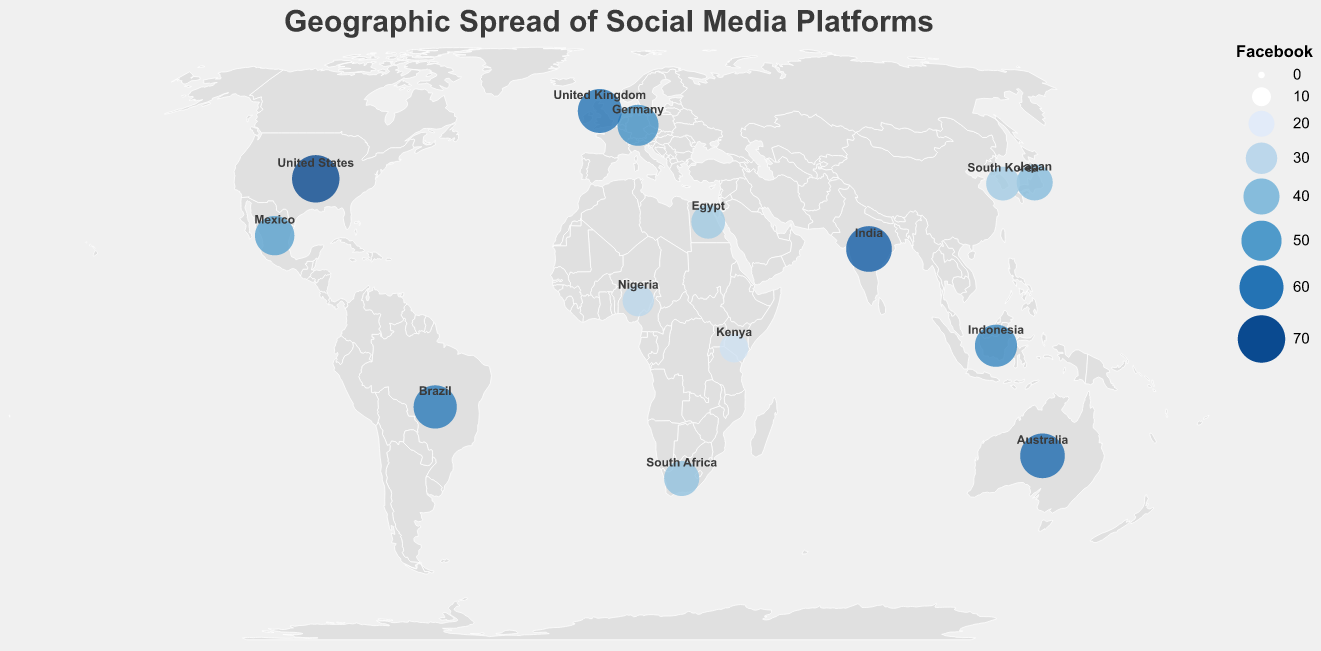What is the title of the figure? The title of the figure is displayed at the top and usually provides a concise summary of what the figure represents. In this case, the title is shown prominently in a specific font and color at the top of the figure.
Answer: Geographic Spread of Social Media Platforms Which country has the highest Facebook user base percentage? By scanning for the largest circle size or the deepest blue color, you can identify the country with the highest Facebook user base. According to the figure, the United States has Facebook usage at 70%.
Answer: United States How does Instagram usage compare between Brazil and Egypt? To compare Instagram usage, look at the tooltip data for both Brazil and Egypt. Brazil has 42% Instagram usage while Egypt has 20%. Hence, Instagram usage in Brazil is higher.
Answer: Brazil has higher Instagram usage Which country has the lowest percentage of Twitter users and what is that percentage? Identify the smallest circle for Twitter users or check the tooltip data for each country. Kenya has the lowest Twitter usage at 6%.
Answer: Kenya with 6% What is the sum of TikTok user base percentages in Indonesia and Japan? Find the TikTok usage percentages for Indonesia and Japan from their tooltips, which are 36% and 18% respectively. Adding these values gives 36 + 18 = 54%.
Answer: 54% How many countries have a Facebook user base percentage greater than 50%? Look at the Facebook usage percentages for each country and count those with values above 50%. The countries are the United States, India, Brazil, Indonesia, Australia, Germany, and the United Kingdom, making a total of 7 countries.
Answer: 7 What is the average Instagram user base percentage across all countries? Sum all Instagram percentages and divide by the number of countries. The sum is 37 + 32 + 42 + 39 + 18 + 15 + 35 + 28 + 30 + 25 + 30 + 35 + 20 + 22 = 408. The number of countries is 14. Average is 408 / 14 ≈ 29.14%.
Answer: 29.14% Which country stands out as having the highest TikTok user base? Look for the tooltip indicating the highest TikTok percentage. South Korea has the highest value at 40%.
Answer: South Korea Compare the social media usage in South Africa for Instagram and Twitter. Which is higher? Use the figure tooltip data to compare Instagram and Twitter percentages for South Africa. Instagram has 22%, and Twitter has 12%. Therefore, Instagram usage is higher.
Answer: Instagram What is the total percentage of social media users if you sum Facebook, Instagram, TikTok, and Twitter for Australia? From the tooltip, Australia has Facebook at 62%, Instagram at 35%, TikTok at 25%, and Twitter at 20%. The sum is 62 + 35 + 25 + 20 = 142%.
Answer: 142% 